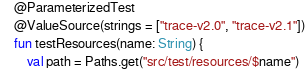Convert code to text. <code><loc_0><loc_0><loc_500><loc_500><_Kotlin_>    @ParameterizedTest
    @ValueSource(strings = ["trace-v2.0", "trace-v2.1"])
    fun testResources(name: String) {
        val path = Paths.get("src/test/resources/$name")</code> 